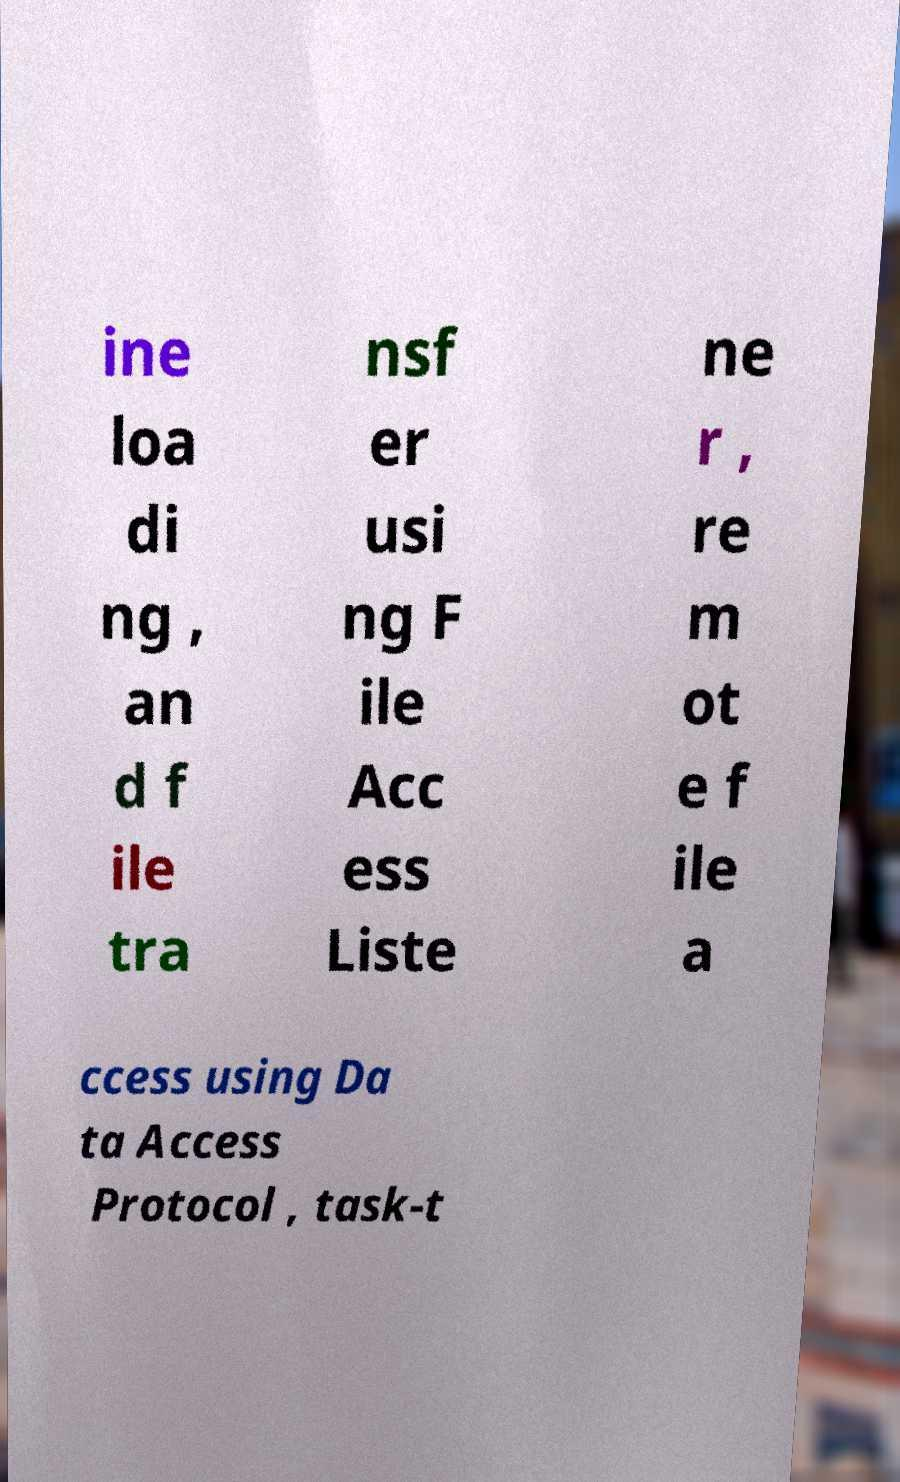Can you accurately transcribe the text from the provided image for me? ine loa di ng , an d f ile tra nsf er usi ng F ile Acc ess Liste ne r , re m ot e f ile a ccess using Da ta Access Protocol , task-t 